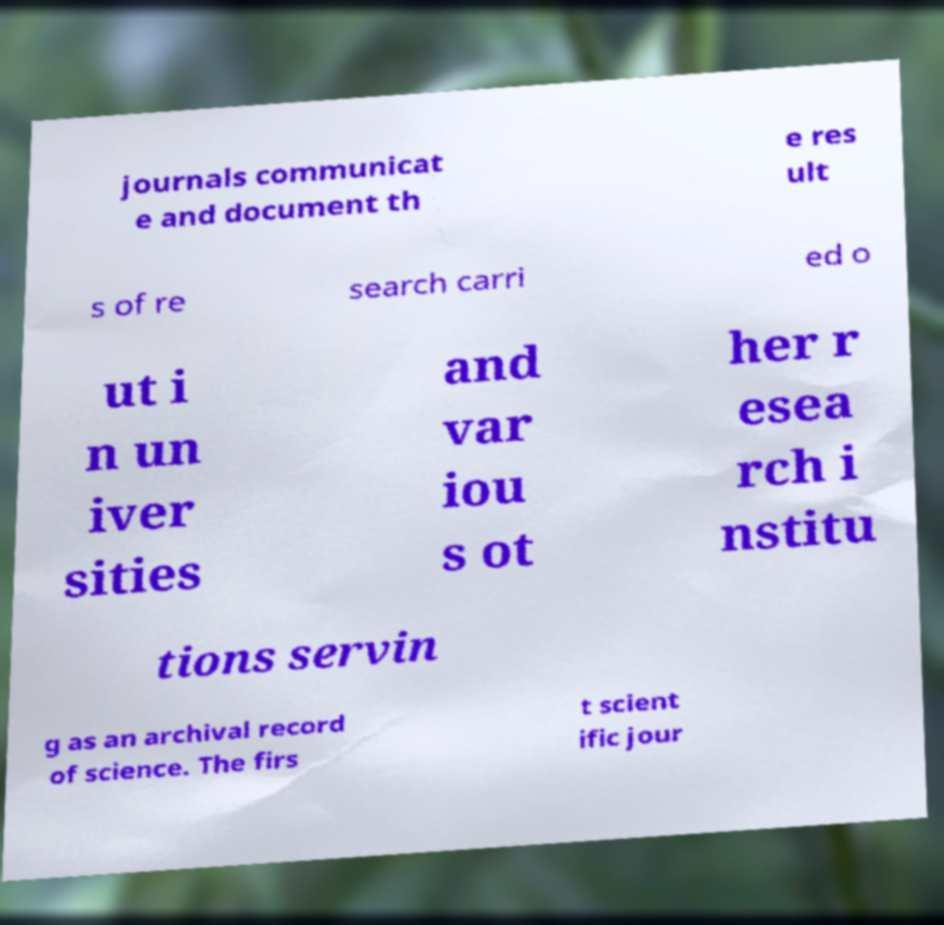Please identify and transcribe the text found in this image. journals communicat e and document th e res ult s of re search carri ed o ut i n un iver sities and var iou s ot her r esea rch i nstitu tions servin g as an archival record of science. The firs t scient ific jour 